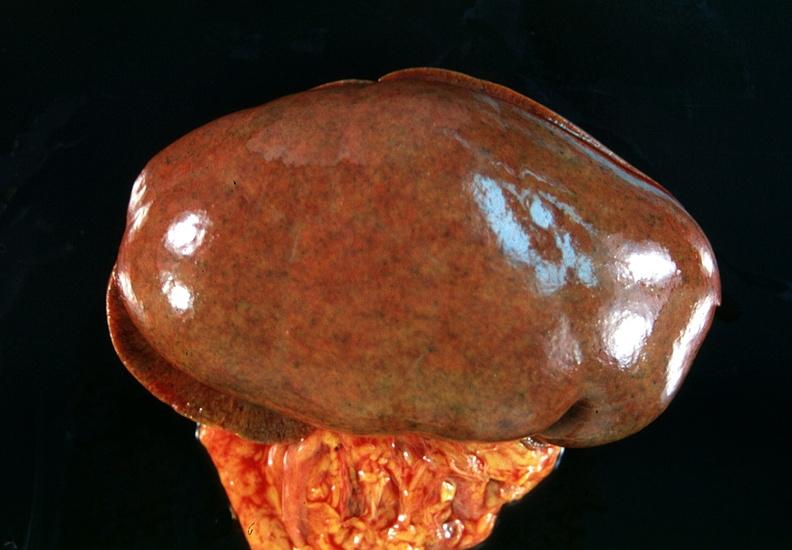what does this image show?
Answer the question using a single word or phrase. Kidney 